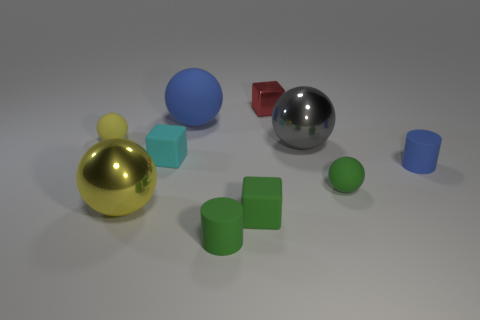Subtract all blue cylinders. How many cylinders are left? 1 Subtract all big yellow balls. How many balls are left? 4 Subtract 2 spheres. How many spheres are left? 3 Subtract all blue spheres. How many red blocks are left? 1 Subtract 1 yellow spheres. How many objects are left? 9 Subtract all cubes. How many objects are left? 7 Subtract all purple blocks. Subtract all cyan cylinders. How many blocks are left? 3 Subtract all tiny yellow matte balls. Subtract all small metallic objects. How many objects are left? 8 Add 5 cyan blocks. How many cyan blocks are left? 6 Add 3 brown matte cubes. How many brown matte cubes exist? 3 